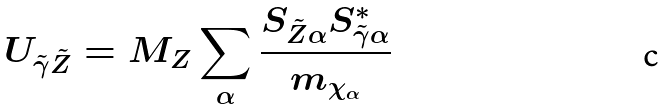Convert formula to latex. <formula><loc_0><loc_0><loc_500><loc_500>U _ { \tilde { \gamma } \tilde { Z } } = M _ { Z } \sum _ { \alpha } \frac { S _ { \tilde { Z } \alpha } S ^ { * } _ { \tilde { \gamma } \alpha } } { m _ { \chi _ { \alpha } } }</formula> 